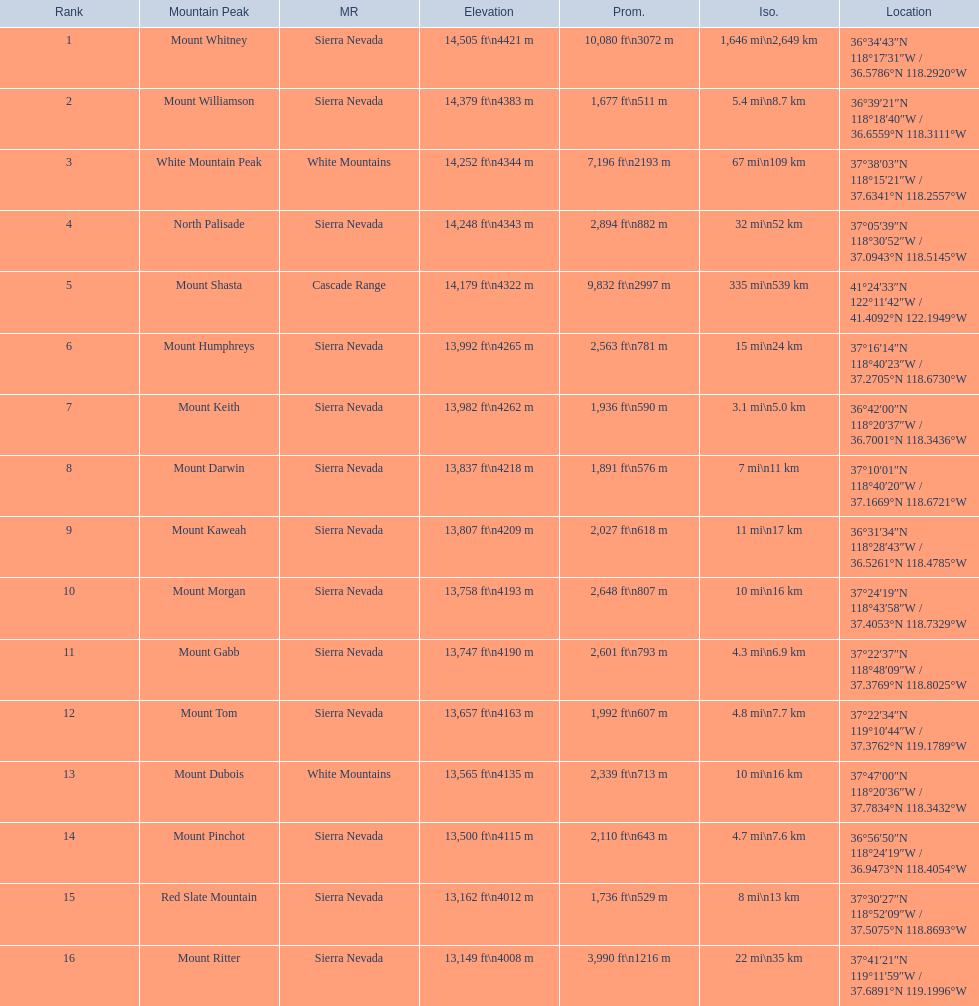What are the mountain peaks? Mount Whitney, Mount Williamson, White Mountain Peak, North Palisade, Mount Shasta, Mount Humphreys, Mount Keith, Mount Darwin, Mount Kaweah, Mount Morgan, Mount Gabb, Mount Tom, Mount Dubois, Mount Pinchot, Red Slate Mountain, Mount Ritter. Of these, which one has a prominence more than 10,000 ft? Mount Whitney. 